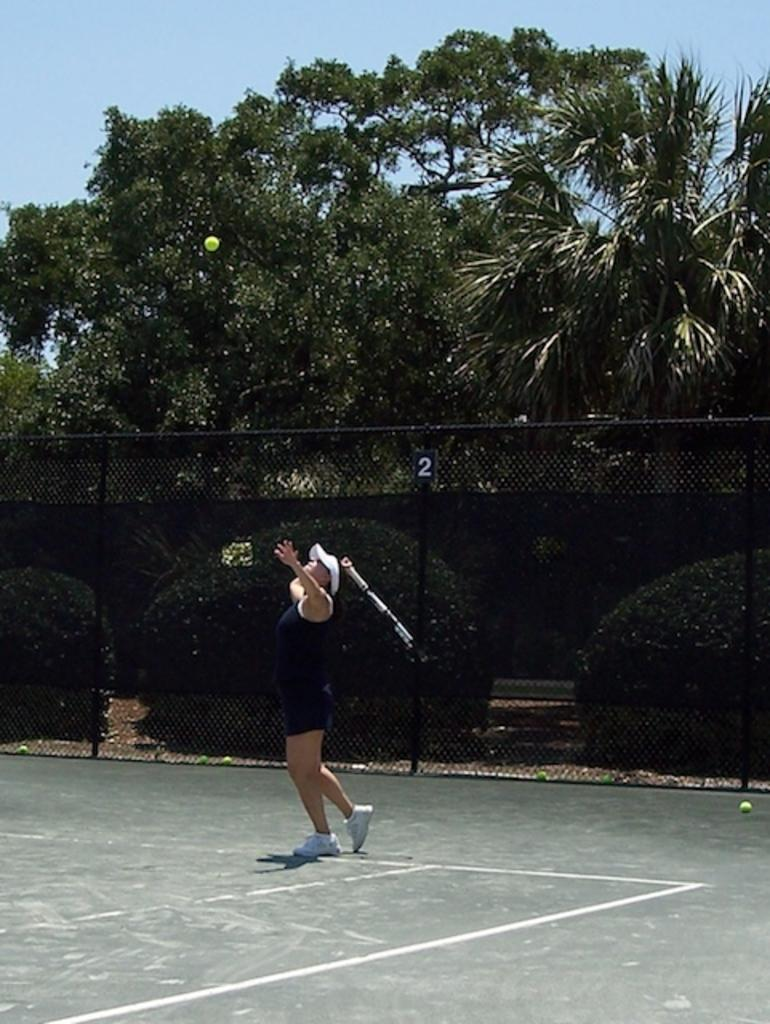What can be seen in the image? There is a person in the image, along with an object they are holding. What is the person standing on in the image? There is ground visible in the image, which the person is standing on. What is the person holding in the image? The person is holding an object, but the specific object is not mentioned in the facts. What type of barrier is present in the image? There is a fence in the image. What type of vegetation is present in the image? There are plants and trees in the image. What type of objects are present in the image? There are balls in the image. What is visible in the sky in the image? The sky is visible in the image. What time of day is it in the image, given that it is night? The facts provided do not mention the time of day or any indication of nighttime in the image. 